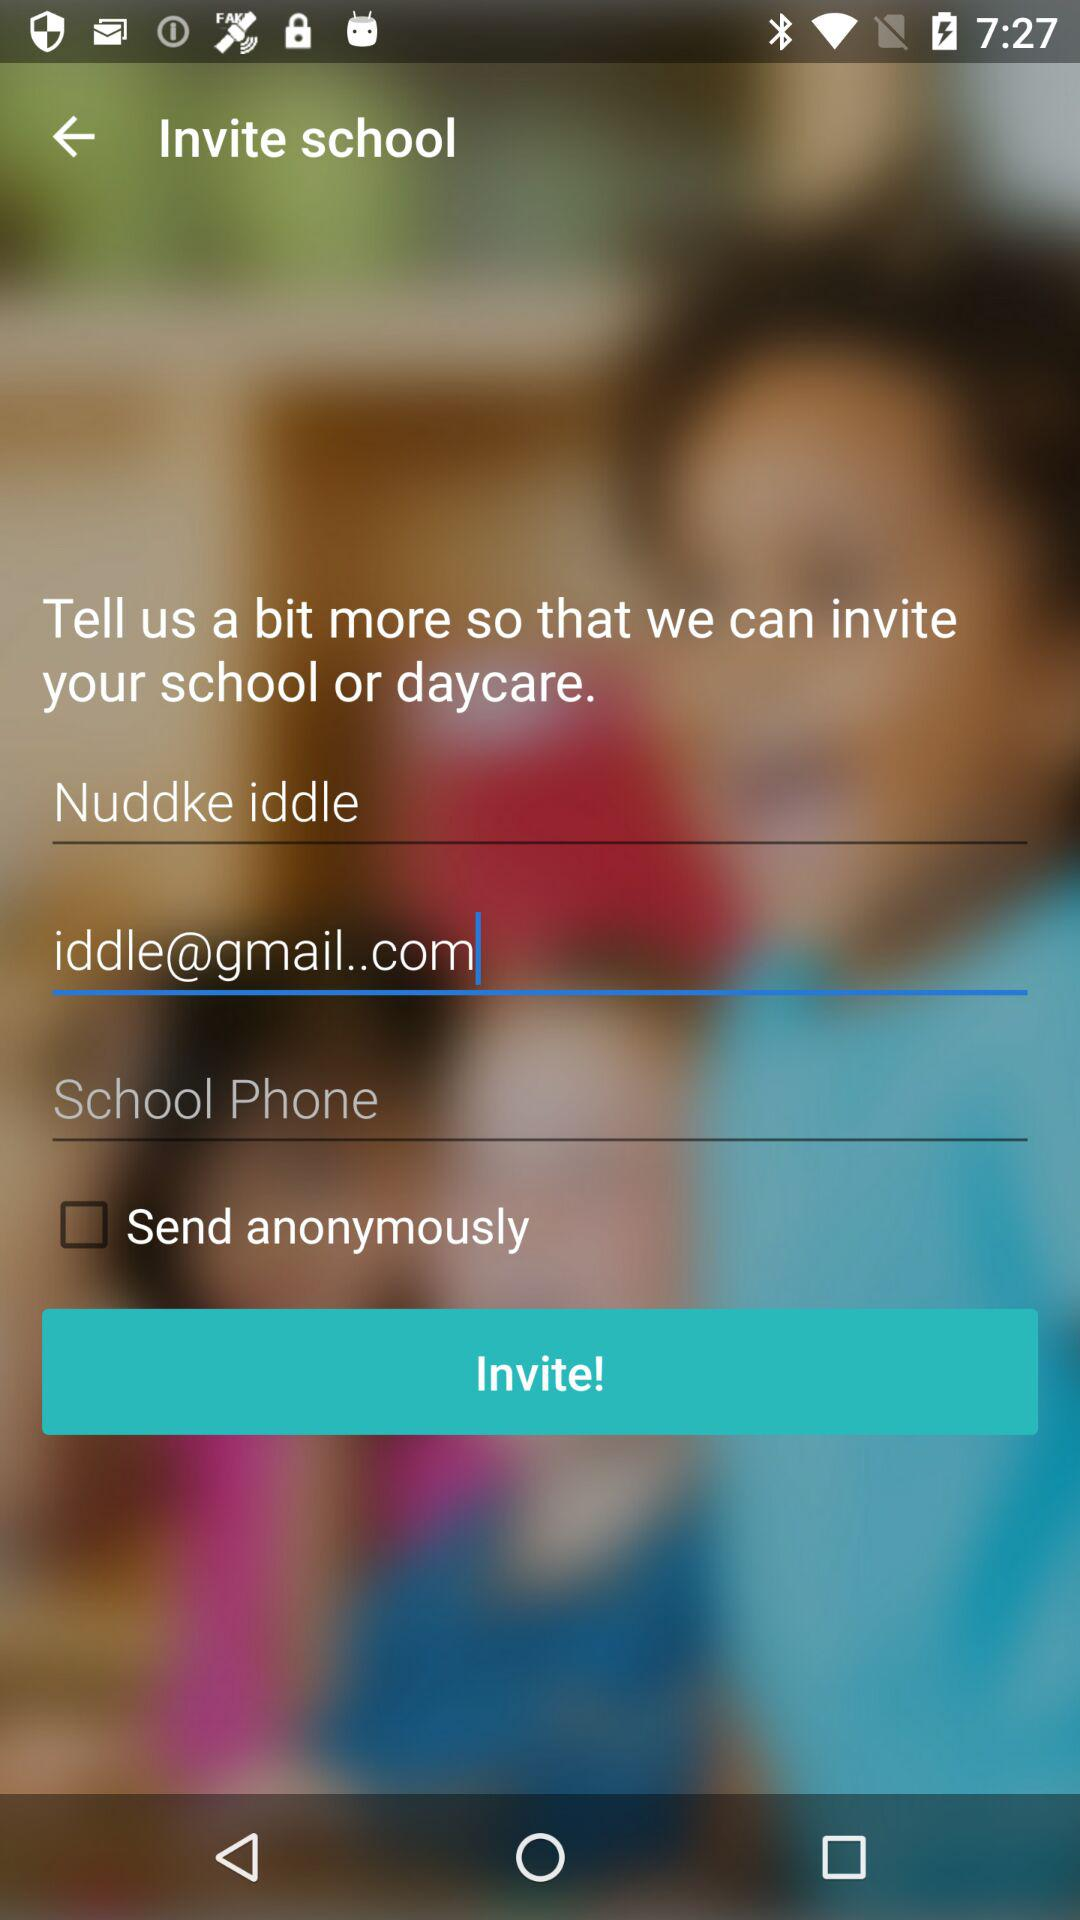What is the status of "Send anonymously"? The status of "Send anonymously" is "off". 